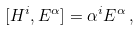Convert formula to latex. <formula><loc_0><loc_0><loc_500><loc_500>[ H ^ { i } , E ^ { \alpha } ] = \alpha ^ { i } E ^ { \alpha } \, ,</formula> 